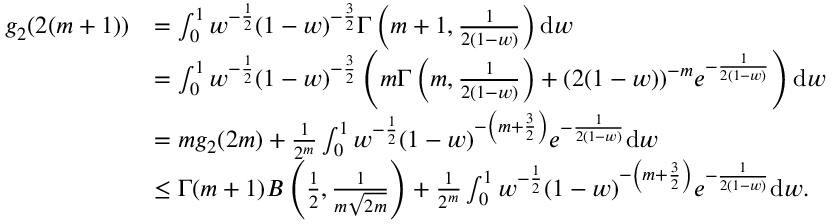Convert formula to latex. <formula><loc_0><loc_0><loc_500><loc_500>\begin{array} { r l } { g _ { 2 } ( 2 ( m + 1 ) ) } & { = \int _ { 0 } ^ { 1 } w ^ { - \frac { 1 } { 2 } } ( 1 - w ) ^ { - \frac { 3 } { 2 } } \Gamma \left ( m + 1 , \frac { 1 } { 2 ( 1 - w ) } \right ) d w } \\ & { = \int _ { 0 } ^ { 1 } w ^ { - \frac { 1 } { 2 } } ( 1 - w ) ^ { - \frac { 3 } { 2 } } \left ( m \Gamma \left ( m , \frac { 1 } { 2 ( 1 - w ) } \right ) + ( 2 ( 1 - w ) ) ^ { - m } e ^ { - \frac { 1 } { 2 ( 1 - w ) } } \right ) d w } \\ & { = m g _ { 2 } ( 2 m ) + \frac { 1 } { 2 ^ { m } } \int _ { 0 } ^ { 1 } w ^ { - \frac { 1 } { 2 } } ( 1 - w ) ^ { - \left ( m + \frac { 3 } { 2 } \right ) } e ^ { - \frac { 1 } { 2 ( 1 - w ) } } d w } \\ & { \leq \Gamma ( m + 1 ) B \left ( \frac { 1 } { 2 } , \frac { 1 } { m \sqrt { 2 m } } \right ) + \frac { 1 } { 2 ^ { m } } \int _ { 0 } ^ { 1 } w ^ { - \frac { 1 } { 2 } } ( 1 - w ) ^ { - \left ( m + \frac { 3 } { 2 } \right ) } e ^ { - \frac { 1 } { 2 ( 1 - w ) } } d w . } \end{array}</formula> 